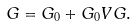<formula> <loc_0><loc_0><loc_500><loc_500>G = G _ { 0 } + G _ { 0 } V G .</formula> 